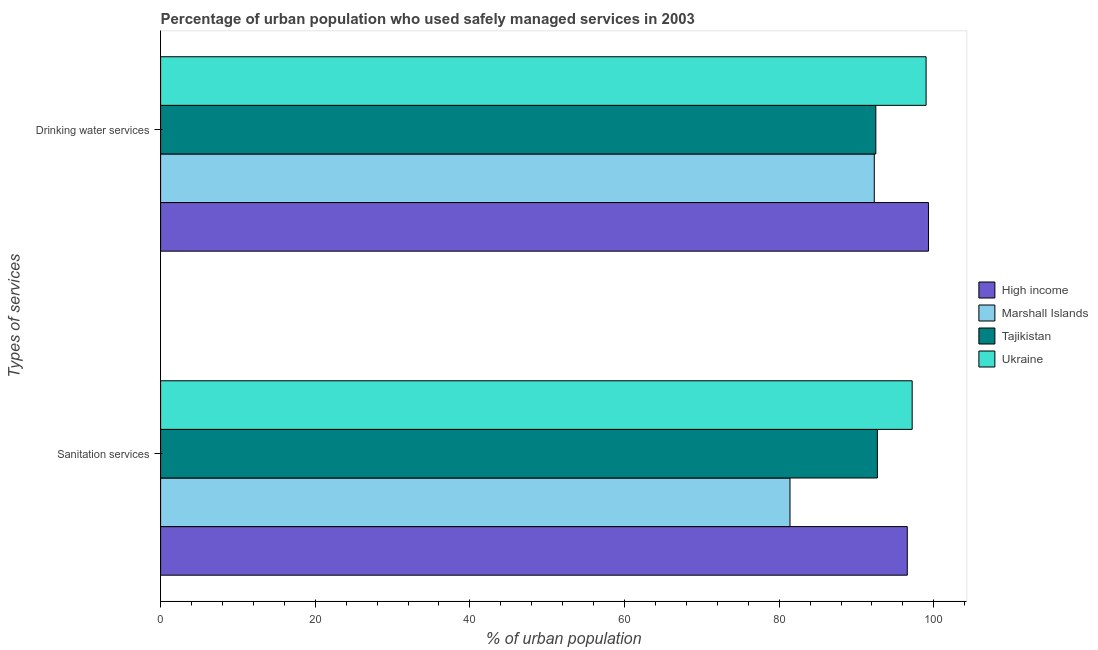How many different coloured bars are there?
Ensure brevity in your answer.  4. Are the number of bars on each tick of the Y-axis equal?
Your answer should be compact. Yes. How many bars are there on the 1st tick from the top?
Ensure brevity in your answer.  4. What is the label of the 2nd group of bars from the top?
Provide a short and direct response. Sanitation services. What is the percentage of urban population who used sanitation services in Ukraine?
Give a very brief answer. 97.2. Across all countries, what is the maximum percentage of urban population who used sanitation services?
Make the answer very short. 97.2. Across all countries, what is the minimum percentage of urban population who used drinking water services?
Offer a very short reply. 92.3. In which country was the percentage of urban population who used drinking water services maximum?
Offer a very short reply. High income. In which country was the percentage of urban population who used sanitation services minimum?
Your answer should be very brief. Marshall Islands. What is the total percentage of urban population who used drinking water services in the graph?
Your response must be concise. 383.11. What is the difference between the percentage of urban population who used sanitation services in High income and that in Ukraine?
Your response must be concise. -0.63. What is the difference between the percentage of urban population who used drinking water services in Ukraine and the percentage of urban population who used sanitation services in Tajikistan?
Keep it short and to the point. 6.3. What is the average percentage of urban population who used drinking water services per country?
Offer a very short reply. 95.78. What is the difference between the percentage of urban population who used drinking water services and percentage of urban population who used sanitation services in Ukraine?
Keep it short and to the point. 1.8. What is the ratio of the percentage of urban population who used drinking water services in High income to that in Marshall Islands?
Ensure brevity in your answer.  1.08. Is the percentage of urban population who used sanitation services in Tajikistan less than that in High income?
Ensure brevity in your answer.  Yes. In how many countries, is the percentage of urban population who used sanitation services greater than the average percentage of urban population who used sanitation services taken over all countries?
Ensure brevity in your answer.  3. What does the 3rd bar from the top in Sanitation services represents?
Provide a short and direct response. Marshall Islands. What does the 3rd bar from the bottom in Drinking water services represents?
Your response must be concise. Tajikistan. How many countries are there in the graph?
Give a very brief answer. 4. Are the values on the major ticks of X-axis written in scientific E-notation?
Provide a short and direct response. No. Does the graph contain grids?
Your answer should be very brief. No. How are the legend labels stacked?
Keep it short and to the point. Vertical. What is the title of the graph?
Keep it short and to the point. Percentage of urban population who used safely managed services in 2003. Does "Comoros" appear as one of the legend labels in the graph?
Give a very brief answer. No. What is the label or title of the X-axis?
Provide a short and direct response. % of urban population. What is the label or title of the Y-axis?
Give a very brief answer. Types of services. What is the % of urban population in High income in Sanitation services?
Offer a terse response. 96.57. What is the % of urban population of Marshall Islands in Sanitation services?
Provide a succinct answer. 81.4. What is the % of urban population of Tajikistan in Sanitation services?
Your answer should be very brief. 92.7. What is the % of urban population of Ukraine in Sanitation services?
Provide a succinct answer. 97.2. What is the % of urban population of High income in Drinking water services?
Give a very brief answer. 99.31. What is the % of urban population of Marshall Islands in Drinking water services?
Your answer should be compact. 92.3. What is the % of urban population of Tajikistan in Drinking water services?
Give a very brief answer. 92.5. Across all Types of services, what is the maximum % of urban population of High income?
Provide a short and direct response. 99.31. Across all Types of services, what is the maximum % of urban population in Marshall Islands?
Offer a terse response. 92.3. Across all Types of services, what is the maximum % of urban population of Tajikistan?
Your response must be concise. 92.7. Across all Types of services, what is the maximum % of urban population in Ukraine?
Keep it short and to the point. 99. Across all Types of services, what is the minimum % of urban population in High income?
Give a very brief answer. 96.57. Across all Types of services, what is the minimum % of urban population of Marshall Islands?
Provide a succinct answer. 81.4. Across all Types of services, what is the minimum % of urban population of Tajikistan?
Ensure brevity in your answer.  92.5. Across all Types of services, what is the minimum % of urban population of Ukraine?
Give a very brief answer. 97.2. What is the total % of urban population of High income in the graph?
Provide a short and direct response. 195.88. What is the total % of urban population in Marshall Islands in the graph?
Offer a terse response. 173.7. What is the total % of urban population in Tajikistan in the graph?
Offer a terse response. 185.2. What is the total % of urban population of Ukraine in the graph?
Offer a terse response. 196.2. What is the difference between the % of urban population of High income in Sanitation services and that in Drinking water services?
Your answer should be very brief. -2.74. What is the difference between the % of urban population of Marshall Islands in Sanitation services and that in Drinking water services?
Make the answer very short. -10.9. What is the difference between the % of urban population of High income in Sanitation services and the % of urban population of Marshall Islands in Drinking water services?
Provide a succinct answer. 4.27. What is the difference between the % of urban population in High income in Sanitation services and the % of urban population in Tajikistan in Drinking water services?
Offer a very short reply. 4.07. What is the difference between the % of urban population in High income in Sanitation services and the % of urban population in Ukraine in Drinking water services?
Provide a short and direct response. -2.43. What is the difference between the % of urban population in Marshall Islands in Sanitation services and the % of urban population in Tajikistan in Drinking water services?
Your answer should be very brief. -11.1. What is the difference between the % of urban population in Marshall Islands in Sanitation services and the % of urban population in Ukraine in Drinking water services?
Give a very brief answer. -17.6. What is the average % of urban population in High income per Types of services?
Provide a succinct answer. 97.94. What is the average % of urban population of Marshall Islands per Types of services?
Provide a succinct answer. 86.85. What is the average % of urban population of Tajikistan per Types of services?
Provide a succinct answer. 92.6. What is the average % of urban population in Ukraine per Types of services?
Your answer should be compact. 98.1. What is the difference between the % of urban population in High income and % of urban population in Marshall Islands in Sanitation services?
Offer a very short reply. 15.17. What is the difference between the % of urban population of High income and % of urban population of Tajikistan in Sanitation services?
Make the answer very short. 3.87. What is the difference between the % of urban population of High income and % of urban population of Ukraine in Sanitation services?
Provide a succinct answer. -0.63. What is the difference between the % of urban population of Marshall Islands and % of urban population of Tajikistan in Sanitation services?
Provide a succinct answer. -11.3. What is the difference between the % of urban population of Marshall Islands and % of urban population of Ukraine in Sanitation services?
Offer a very short reply. -15.8. What is the difference between the % of urban population of Tajikistan and % of urban population of Ukraine in Sanitation services?
Keep it short and to the point. -4.5. What is the difference between the % of urban population in High income and % of urban population in Marshall Islands in Drinking water services?
Your answer should be very brief. 7.01. What is the difference between the % of urban population in High income and % of urban population in Tajikistan in Drinking water services?
Keep it short and to the point. 6.81. What is the difference between the % of urban population in High income and % of urban population in Ukraine in Drinking water services?
Offer a very short reply. 0.31. What is the ratio of the % of urban population of High income in Sanitation services to that in Drinking water services?
Your response must be concise. 0.97. What is the ratio of the % of urban population of Marshall Islands in Sanitation services to that in Drinking water services?
Ensure brevity in your answer.  0.88. What is the ratio of the % of urban population of Ukraine in Sanitation services to that in Drinking water services?
Make the answer very short. 0.98. What is the difference between the highest and the second highest % of urban population in High income?
Make the answer very short. 2.74. What is the difference between the highest and the second highest % of urban population of Ukraine?
Offer a terse response. 1.8. What is the difference between the highest and the lowest % of urban population of High income?
Make the answer very short. 2.74. What is the difference between the highest and the lowest % of urban population in Marshall Islands?
Give a very brief answer. 10.9. What is the difference between the highest and the lowest % of urban population of Tajikistan?
Your answer should be compact. 0.2. What is the difference between the highest and the lowest % of urban population in Ukraine?
Provide a short and direct response. 1.8. 